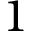<formula> <loc_0><loc_0><loc_500><loc_500>1</formula> 